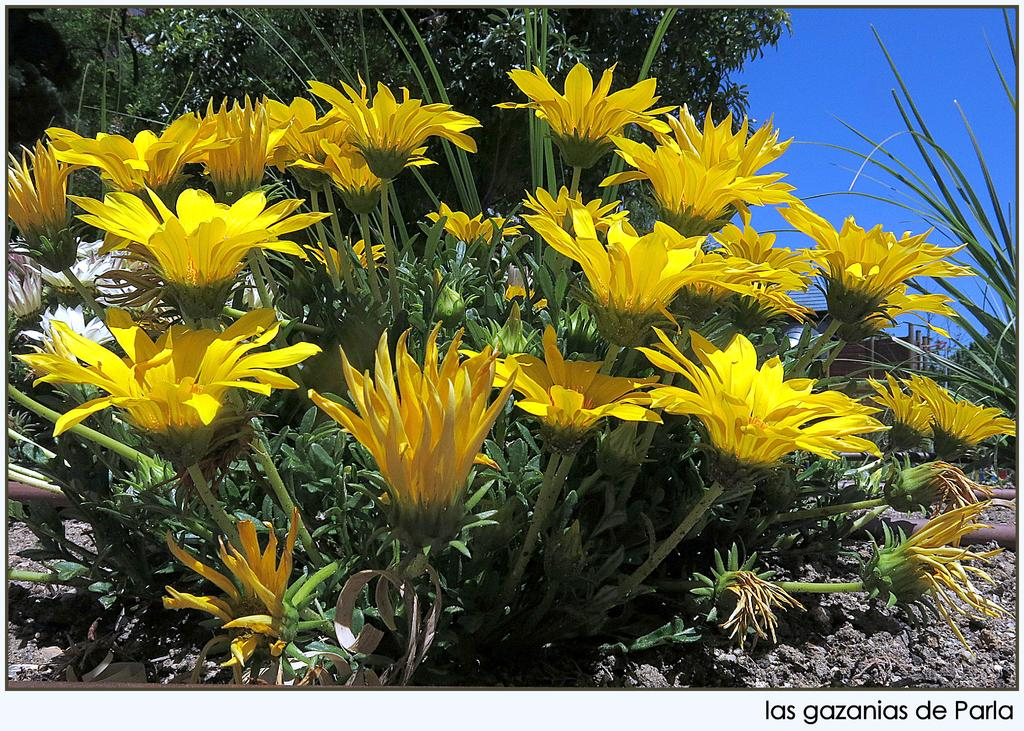What type of plant is present in the image? There is a plant with yellow flowers in the image. What can be seen in the background of the image? There are trees and the sky visible in the background of the image. What is at the bottom of the image? There is mud at the bottom of the image. How does the beggar feel about the thread in the image? There is no beggar or thread present in the image. 